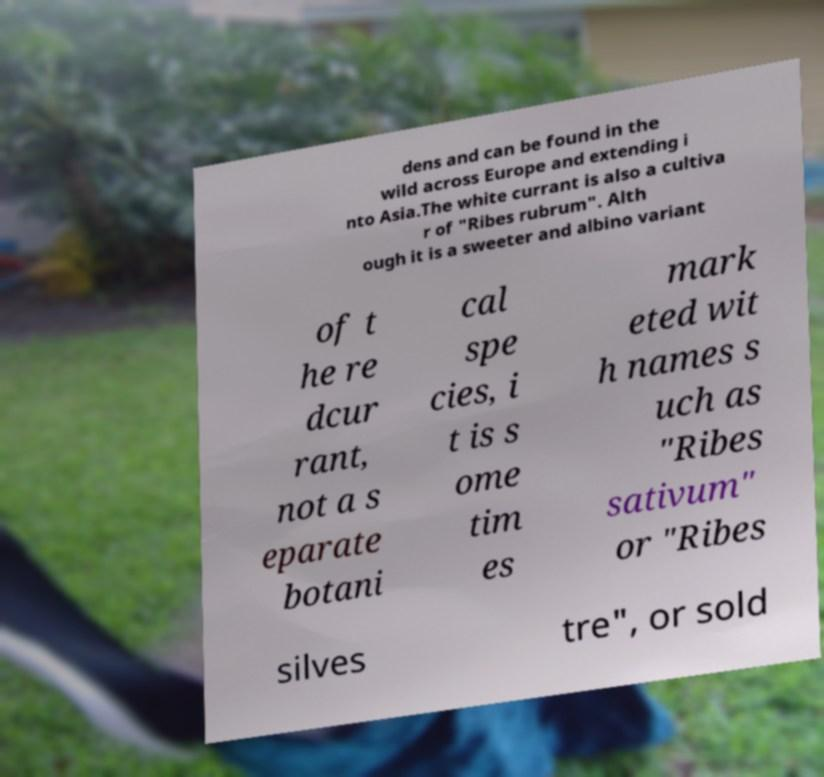Could you extract and type out the text from this image? dens and can be found in the wild across Europe and extending i nto Asia.The white currant is also a cultiva r of "Ribes rubrum". Alth ough it is a sweeter and albino variant of t he re dcur rant, not a s eparate botani cal spe cies, i t is s ome tim es mark eted wit h names s uch as "Ribes sativum" or "Ribes silves tre", or sold 